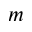<formula> <loc_0><loc_0><loc_500><loc_500>m</formula> 